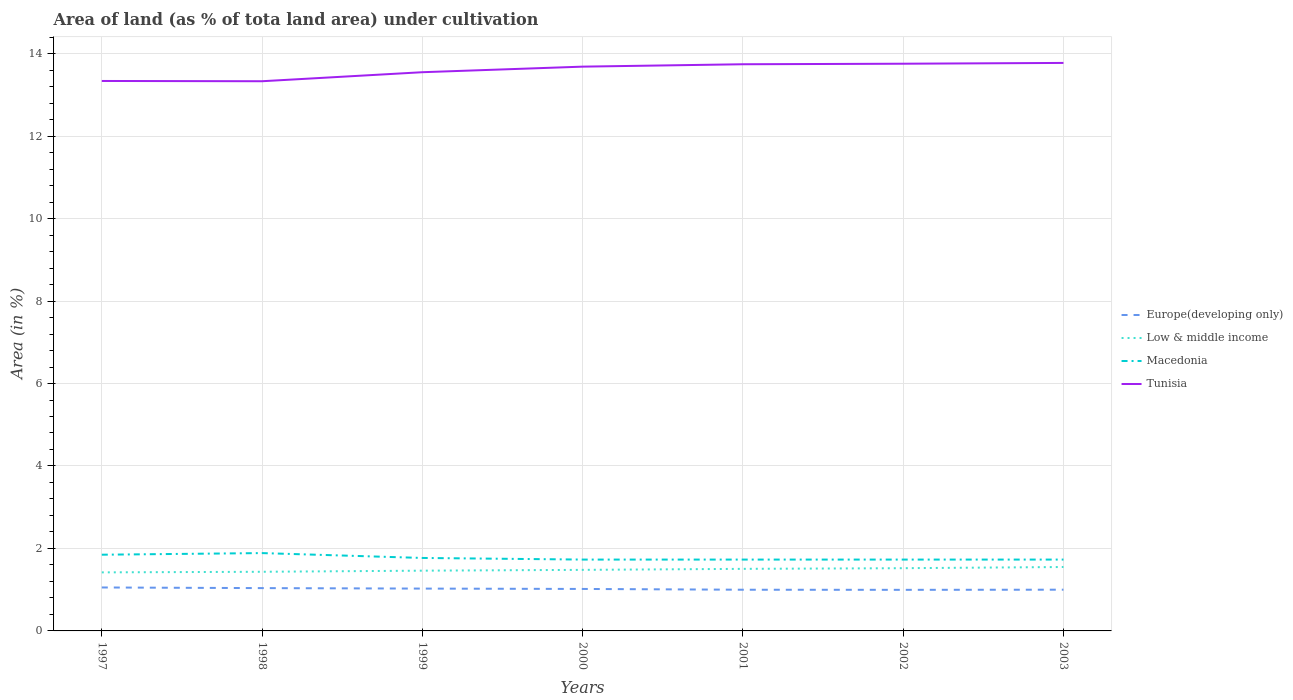Is the number of lines equal to the number of legend labels?
Provide a short and direct response. Yes. Across all years, what is the maximum percentage of land under cultivation in Macedonia?
Offer a very short reply. 1.73. In which year was the percentage of land under cultivation in Low & middle income maximum?
Make the answer very short. 1997. What is the total percentage of land under cultivation in Europe(developing only) in the graph?
Your answer should be compact. 0.03. What is the difference between the highest and the second highest percentage of land under cultivation in Europe(developing only)?
Provide a succinct answer. 0.06. What is the difference between the highest and the lowest percentage of land under cultivation in Low & middle income?
Offer a terse response. 3. What is the difference between two consecutive major ticks on the Y-axis?
Your answer should be very brief. 2. Does the graph contain any zero values?
Ensure brevity in your answer.  No. Does the graph contain grids?
Offer a very short reply. Yes. How many legend labels are there?
Ensure brevity in your answer.  4. What is the title of the graph?
Your answer should be very brief. Area of land (as % of tota land area) under cultivation. Does "Sub-Saharan Africa (developing only)" appear as one of the legend labels in the graph?
Your response must be concise. No. What is the label or title of the Y-axis?
Your answer should be compact. Area (in %). What is the Area (in %) in Europe(developing only) in 1997?
Provide a short and direct response. 1.05. What is the Area (in %) in Low & middle income in 1997?
Give a very brief answer. 1.42. What is the Area (in %) in Macedonia in 1997?
Your answer should be compact. 1.85. What is the Area (in %) in Tunisia in 1997?
Keep it short and to the point. 13.34. What is the Area (in %) in Europe(developing only) in 1998?
Make the answer very short. 1.04. What is the Area (in %) of Low & middle income in 1998?
Your response must be concise. 1.43. What is the Area (in %) in Macedonia in 1998?
Your response must be concise. 1.89. What is the Area (in %) in Tunisia in 1998?
Your response must be concise. 13.33. What is the Area (in %) in Europe(developing only) in 1999?
Your answer should be very brief. 1.03. What is the Area (in %) in Low & middle income in 1999?
Provide a short and direct response. 1.46. What is the Area (in %) of Macedonia in 1999?
Offer a very short reply. 1.77. What is the Area (in %) of Tunisia in 1999?
Give a very brief answer. 13.55. What is the Area (in %) in Europe(developing only) in 2000?
Offer a terse response. 1.02. What is the Area (in %) of Low & middle income in 2000?
Keep it short and to the point. 1.48. What is the Area (in %) of Macedonia in 2000?
Your response must be concise. 1.73. What is the Area (in %) in Tunisia in 2000?
Offer a very short reply. 13.68. What is the Area (in %) of Europe(developing only) in 2001?
Ensure brevity in your answer.  1. What is the Area (in %) in Low & middle income in 2001?
Keep it short and to the point. 1.51. What is the Area (in %) of Macedonia in 2001?
Your answer should be very brief. 1.73. What is the Area (in %) of Tunisia in 2001?
Provide a short and direct response. 13.74. What is the Area (in %) of Europe(developing only) in 2002?
Provide a succinct answer. 1. What is the Area (in %) in Low & middle income in 2002?
Your answer should be compact. 1.52. What is the Area (in %) of Macedonia in 2002?
Make the answer very short. 1.73. What is the Area (in %) of Tunisia in 2002?
Offer a terse response. 13.76. What is the Area (in %) in Europe(developing only) in 2003?
Make the answer very short. 1. What is the Area (in %) of Low & middle income in 2003?
Your response must be concise. 1.55. What is the Area (in %) in Macedonia in 2003?
Keep it short and to the point. 1.73. What is the Area (in %) in Tunisia in 2003?
Provide a short and direct response. 13.77. Across all years, what is the maximum Area (in %) of Europe(developing only)?
Provide a short and direct response. 1.05. Across all years, what is the maximum Area (in %) of Low & middle income?
Offer a very short reply. 1.55. Across all years, what is the maximum Area (in %) in Macedonia?
Ensure brevity in your answer.  1.89. Across all years, what is the maximum Area (in %) in Tunisia?
Make the answer very short. 13.77. Across all years, what is the minimum Area (in %) in Europe(developing only)?
Ensure brevity in your answer.  1. Across all years, what is the minimum Area (in %) of Low & middle income?
Your answer should be very brief. 1.42. Across all years, what is the minimum Area (in %) in Macedonia?
Ensure brevity in your answer.  1.73. Across all years, what is the minimum Area (in %) of Tunisia?
Give a very brief answer. 13.33. What is the total Area (in %) of Europe(developing only) in the graph?
Ensure brevity in your answer.  7.13. What is the total Area (in %) in Low & middle income in the graph?
Offer a terse response. 10.37. What is the total Area (in %) of Macedonia in the graph?
Your answer should be very brief. 12.43. What is the total Area (in %) in Tunisia in the graph?
Provide a succinct answer. 95.17. What is the difference between the Area (in %) of Europe(developing only) in 1997 and that in 1998?
Offer a very short reply. 0.02. What is the difference between the Area (in %) in Low & middle income in 1997 and that in 1998?
Your answer should be very brief. -0.01. What is the difference between the Area (in %) of Macedonia in 1997 and that in 1998?
Your answer should be compact. -0.04. What is the difference between the Area (in %) of Tunisia in 1997 and that in 1998?
Provide a succinct answer. 0.01. What is the difference between the Area (in %) of Europe(developing only) in 1997 and that in 1999?
Offer a terse response. 0.03. What is the difference between the Area (in %) of Low & middle income in 1997 and that in 1999?
Provide a short and direct response. -0.04. What is the difference between the Area (in %) of Macedonia in 1997 and that in 1999?
Offer a very short reply. 0.08. What is the difference between the Area (in %) of Tunisia in 1997 and that in 1999?
Your response must be concise. -0.21. What is the difference between the Area (in %) of Europe(developing only) in 1997 and that in 2000?
Provide a succinct answer. 0.04. What is the difference between the Area (in %) of Low & middle income in 1997 and that in 2000?
Your response must be concise. -0.06. What is the difference between the Area (in %) in Macedonia in 1997 and that in 2000?
Keep it short and to the point. 0.12. What is the difference between the Area (in %) in Tunisia in 1997 and that in 2000?
Keep it short and to the point. -0.35. What is the difference between the Area (in %) in Europe(developing only) in 1997 and that in 2001?
Give a very brief answer. 0.05. What is the difference between the Area (in %) of Low & middle income in 1997 and that in 2001?
Give a very brief answer. -0.09. What is the difference between the Area (in %) of Macedonia in 1997 and that in 2001?
Ensure brevity in your answer.  0.12. What is the difference between the Area (in %) in Tunisia in 1997 and that in 2001?
Provide a short and direct response. -0.41. What is the difference between the Area (in %) of Europe(developing only) in 1997 and that in 2002?
Your answer should be compact. 0.06. What is the difference between the Area (in %) of Low & middle income in 1997 and that in 2002?
Offer a very short reply. -0.1. What is the difference between the Area (in %) of Macedonia in 1997 and that in 2002?
Give a very brief answer. 0.12. What is the difference between the Area (in %) of Tunisia in 1997 and that in 2002?
Your response must be concise. -0.42. What is the difference between the Area (in %) of Europe(developing only) in 1997 and that in 2003?
Provide a short and direct response. 0.05. What is the difference between the Area (in %) of Low & middle income in 1997 and that in 2003?
Keep it short and to the point. -0.13. What is the difference between the Area (in %) of Macedonia in 1997 and that in 2003?
Offer a terse response. 0.12. What is the difference between the Area (in %) of Tunisia in 1997 and that in 2003?
Your answer should be compact. -0.44. What is the difference between the Area (in %) of Europe(developing only) in 1998 and that in 1999?
Provide a short and direct response. 0.01. What is the difference between the Area (in %) in Low & middle income in 1998 and that in 1999?
Give a very brief answer. -0.03. What is the difference between the Area (in %) in Macedonia in 1998 and that in 1999?
Offer a terse response. 0.12. What is the difference between the Area (in %) in Tunisia in 1998 and that in 1999?
Provide a short and direct response. -0.22. What is the difference between the Area (in %) of Europe(developing only) in 1998 and that in 2000?
Make the answer very short. 0.02. What is the difference between the Area (in %) in Low & middle income in 1998 and that in 2000?
Ensure brevity in your answer.  -0.05. What is the difference between the Area (in %) in Macedonia in 1998 and that in 2000?
Make the answer very short. 0.16. What is the difference between the Area (in %) in Tunisia in 1998 and that in 2000?
Offer a terse response. -0.35. What is the difference between the Area (in %) of Europe(developing only) in 1998 and that in 2001?
Offer a very short reply. 0.04. What is the difference between the Area (in %) of Low & middle income in 1998 and that in 2001?
Provide a short and direct response. -0.07. What is the difference between the Area (in %) in Macedonia in 1998 and that in 2001?
Offer a very short reply. 0.16. What is the difference between the Area (in %) of Tunisia in 1998 and that in 2001?
Your answer should be very brief. -0.41. What is the difference between the Area (in %) of Europe(developing only) in 1998 and that in 2002?
Provide a short and direct response. 0.04. What is the difference between the Area (in %) in Low & middle income in 1998 and that in 2002?
Provide a succinct answer. -0.09. What is the difference between the Area (in %) of Macedonia in 1998 and that in 2002?
Your answer should be compact. 0.16. What is the difference between the Area (in %) in Tunisia in 1998 and that in 2002?
Provide a succinct answer. -0.42. What is the difference between the Area (in %) of Europe(developing only) in 1998 and that in 2003?
Keep it short and to the point. 0.04. What is the difference between the Area (in %) in Low & middle income in 1998 and that in 2003?
Make the answer very short. -0.12. What is the difference between the Area (in %) in Macedonia in 1998 and that in 2003?
Offer a terse response. 0.16. What is the difference between the Area (in %) in Tunisia in 1998 and that in 2003?
Provide a succinct answer. -0.44. What is the difference between the Area (in %) of Europe(developing only) in 1999 and that in 2000?
Keep it short and to the point. 0.01. What is the difference between the Area (in %) in Low & middle income in 1999 and that in 2000?
Give a very brief answer. -0.02. What is the difference between the Area (in %) in Macedonia in 1999 and that in 2000?
Provide a succinct answer. 0.04. What is the difference between the Area (in %) of Tunisia in 1999 and that in 2000?
Offer a terse response. -0.14. What is the difference between the Area (in %) in Europe(developing only) in 1999 and that in 2001?
Your answer should be very brief. 0.03. What is the difference between the Area (in %) in Low & middle income in 1999 and that in 2001?
Keep it short and to the point. -0.04. What is the difference between the Area (in %) in Macedonia in 1999 and that in 2001?
Keep it short and to the point. 0.04. What is the difference between the Area (in %) of Tunisia in 1999 and that in 2001?
Keep it short and to the point. -0.19. What is the difference between the Area (in %) in Europe(developing only) in 1999 and that in 2002?
Your answer should be compact. 0.03. What is the difference between the Area (in %) in Low & middle income in 1999 and that in 2002?
Provide a short and direct response. -0.06. What is the difference between the Area (in %) in Macedonia in 1999 and that in 2002?
Your answer should be very brief. 0.04. What is the difference between the Area (in %) in Tunisia in 1999 and that in 2002?
Your answer should be very brief. -0.21. What is the difference between the Area (in %) in Europe(developing only) in 1999 and that in 2003?
Offer a very short reply. 0.03. What is the difference between the Area (in %) of Low & middle income in 1999 and that in 2003?
Make the answer very short. -0.09. What is the difference between the Area (in %) of Macedonia in 1999 and that in 2003?
Make the answer very short. 0.04. What is the difference between the Area (in %) in Tunisia in 1999 and that in 2003?
Your answer should be very brief. -0.23. What is the difference between the Area (in %) in Europe(developing only) in 2000 and that in 2001?
Make the answer very short. 0.02. What is the difference between the Area (in %) in Low & middle income in 2000 and that in 2001?
Keep it short and to the point. -0.02. What is the difference between the Area (in %) of Macedonia in 2000 and that in 2001?
Provide a succinct answer. 0. What is the difference between the Area (in %) of Tunisia in 2000 and that in 2001?
Your answer should be compact. -0.06. What is the difference between the Area (in %) in Europe(developing only) in 2000 and that in 2002?
Offer a terse response. 0.02. What is the difference between the Area (in %) in Low & middle income in 2000 and that in 2002?
Make the answer very short. -0.04. What is the difference between the Area (in %) in Tunisia in 2000 and that in 2002?
Your answer should be compact. -0.07. What is the difference between the Area (in %) of Europe(developing only) in 2000 and that in 2003?
Your answer should be compact. 0.02. What is the difference between the Area (in %) of Low & middle income in 2000 and that in 2003?
Ensure brevity in your answer.  -0.07. What is the difference between the Area (in %) of Macedonia in 2000 and that in 2003?
Your response must be concise. 0. What is the difference between the Area (in %) in Tunisia in 2000 and that in 2003?
Provide a short and direct response. -0.09. What is the difference between the Area (in %) of Europe(developing only) in 2001 and that in 2002?
Your answer should be very brief. 0. What is the difference between the Area (in %) of Low & middle income in 2001 and that in 2002?
Your response must be concise. -0.02. What is the difference between the Area (in %) in Tunisia in 2001 and that in 2002?
Your answer should be very brief. -0.01. What is the difference between the Area (in %) in Europe(developing only) in 2001 and that in 2003?
Provide a succinct answer. -0. What is the difference between the Area (in %) of Low & middle income in 2001 and that in 2003?
Ensure brevity in your answer.  -0.04. What is the difference between the Area (in %) of Macedonia in 2001 and that in 2003?
Ensure brevity in your answer.  0. What is the difference between the Area (in %) in Tunisia in 2001 and that in 2003?
Your answer should be very brief. -0.03. What is the difference between the Area (in %) of Europe(developing only) in 2002 and that in 2003?
Your answer should be very brief. -0. What is the difference between the Area (in %) in Low & middle income in 2002 and that in 2003?
Make the answer very short. -0.03. What is the difference between the Area (in %) of Macedonia in 2002 and that in 2003?
Ensure brevity in your answer.  0. What is the difference between the Area (in %) in Tunisia in 2002 and that in 2003?
Your answer should be very brief. -0.02. What is the difference between the Area (in %) in Europe(developing only) in 1997 and the Area (in %) in Low & middle income in 1998?
Offer a terse response. -0.38. What is the difference between the Area (in %) of Europe(developing only) in 1997 and the Area (in %) of Macedonia in 1998?
Offer a very short reply. -0.83. What is the difference between the Area (in %) of Europe(developing only) in 1997 and the Area (in %) of Tunisia in 1998?
Ensure brevity in your answer.  -12.28. What is the difference between the Area (in %) in Low & middle income in 1997 and the Area (in %) in Macedonia in 1998?
Your answer should be very brief. -0.47. What is the difference between the Area (in %) in Low & middle income in 1997 and the Area (in %) in Tunisia in 1998?
Offer a very short reply. -11.91. What is the difference between the Area (in %) in Macedonia in 1997 and the Area (in %) in Tunisia in 1998?
Offer a terse response. -11.48. What is the difference between the Area (in %) of Europe(developing only) in 1997 and the Area (in %) of Low & middle income in 1999?
Your response must be concise. -0.41. What is the difference between the Area (in %) of Europe(developing only) in 1997 and the Area (in %) of Macedonia in 1999?
Provide a short and direct response. -0.72. What is the difference between the Area (in %) of Europe(developing only) in 1997 and the Area (in %) of Tunisia in 1999?
Keep it short and to the point. -12.5. What is the difference between the Area (in %) of Low & middle income in 1997 and the Area (in %) of Macedonia in 1999?
Ensure brevity in your answer.  -0.35. What is the difference between the Area (in %) of Low & middle income in 1997 and the Area (in %) of Tunisia in 1999?
Offer a terse response. -12.13. What is the difference between the Area (in %) in Macedonia in 1997 and the Area (in %) in Tunisia in 1999?
Your answer should be compact. -11.7. What is the difference between the Area (in %) of Europe(developing only) in 1997 and the Area (in %) of Low & middle income in 2000?
Give a very brief answer. -0.43. What is the difference between the Area (in %) of Europe(developing only) in 1997 and the Area (in %) of Macedonia in 2000?
Your answer should be very brief. -0.68. What is the difference between the Area (in %) of Europe(developing only) in 1997 and the Area (in %) of Tunisia in 2000?
Keep it short and to the point. -12.63. What is the difference between the Area (in %) of Low & middle income in 1997 and the Area (in %) of Macedonia in 2000?
Offer a terse response. -0.31. What is the difference between the Area (in %) of Low & middle income in 1997 and the Area (in %) of Tunisia in 2000?
Give a very brief answer. -12.26. What is the difference between the Area (in %) of Macedonia in 1997 and the Area (in %) of Tunisia in 2000?
Offer a very short reply. -11.84. What is the difference between the Area (in %) of Europe(developing only) in 1997 and the Area (in %) of Low & middle income in 2001?
Ensure brevity in your answer.  -0.45. What is the difference between the Area (in %) of Europe(developing only) in 1997 and the Area (in %) of Macedonia in 2001?
Provide a short and direct response. -0.68. What is the difference between the Area (in %) of Europe(developing only) in 1997 and the Area (in %) of Tunisia in 2001?
Provide a short and direct response. -12.69. What is the difference between the Area (in %) in Low & middle income in 1997 and the Area (in %) in Macedonia in 2001?
Your response must be concise. -0.31. What is the difference between the Area (in %) of Low & middle income in 1997 and the Area (in %) of Tunisia in 2001?
Offer a terse response. -12.32. What is the difference between the Area (in %) of Macedonia in 1997 and the Area (in %) of Tunisia in 2001?
Offer a terse response. -11.89. What is the difference between the Area (in %) of Europe(developing only) in 1997 and the Area (in %) of Low & middle income in 2002?
Your answer should be compact. -0.47. What is the difference between the Area (in %) in Europe(developing only) in 1997 and the Area (in %) in Macedonia in 2002?
Make the answer very short. -0.68. What is the difference between the Area (in %) of Europe(developing only) in 1997 and the Area (in %) of Tunisia in 2002?
Your answer should be very brief. -12.7. What is the difference between the Area (in %) in Low & middle income in 1997 and the Area (in %) in Macedonia in 2002?
Give a very brief answer. -0.31. What is the difference between the Area (in %) in Low & middle income in 1997 and the Area (in %) in Tunisia in 2002?
Offer a very short reply. -12.34. What is the difference between the Area (in %) in Macedonia in 1997 and the Area (in %) in Tunisia in 2002?
Make the answer very short. -11.91. What is the difference between the Area (in %) of Europe(developing only) in 1997 and the Area (in %) of Low & middle income in 2003?
Provide a short and direct response. -0.5. What is the difference between the Area (in %) of Europe(developing only) in 1997 and the Area (in %) of Macedonia in 2003?
Your response must be concise. -0.68. What is the difference between the Area (in %) in Europe(developing only) in 1997 and the Area (in %) in Tunisia in 2003?
Offer a very short reply. -12.72. What is the difference between the Area (in %) of Low & middle income in 1997 and the Area (in %) of Macedonia in 2003?
Offer a very short reply. -0.31. What is the difference between the Area (in %) of Low & middle income in 1997 and the Area (in %) of Tunisia in 2003?
Provide a short and direct response. -12.35. What is the difference between the Area (in %) of Macedonia in 1997 and the Area (in %) of Tunisia in 2003?
Your answer should be very brief. -11.93. What is the difference between the Area (in %) in Europe(developing only) in 1998 and the Area (in %) in Low & middle income in 1999?
Your response must be concise. -0.42. What is the difference between the Area (in %) of Europe(developing only) in 1998 and the Area (in %) of Macedonia in 1999?
Your answer should be very brief. -0.73. What is the difference between the Area (in %) of Europe(developing only) in 1998 and the Area (in %) of Tunisia in 1999?
Provide a succinct answer. -12.51. What is the difference between the Area (in %) of Low & middle income in 1998 and the Area (in %) of Macedonia in 1999?
Your answer should be very brief. -0.34. What is the difference between the Area (in %) of Low & middle income in 1998 and the Area (in %) of Tunisia in 1999?
Your response must be concise. -12.11. What is the difference between the Area (in %) of Macedonia in 1998 and the Area (in %) of Tunisia in 1999?
Provide a short and direct response. -11.66. What is the difference between the Area (in %) in Europe(developing only) in 1998 and the Area (in %) in Low & middle income in 2000?
Offer a terse response. -0.44. What is the difference between the Area (in %) of Europe(developing only) in 1998 and the Area (in %) of Macedonia in 2000?
Give a very brief answer. -0.69. What is the difference between the Area (in %) in Europe(developing only) in 1998 and the Area (in %) in Tunisia in 2000?
Keep it short and to the point. -12.65. What is the difference between the Area (in %) of Low & middle income in 1998 and the Area (in %) of Macedonia in 2000?
Make the answer very short. -0.3. What is the difference between the Area (in %) of Low & middle income in 1998 and the Area (in %) of Tunisia in 2000?
Offer a terse response. -12.25. What is the difference between the Area (in %) in Macedonia in 1998 and the Area (in %) in Tunisia in 2000?
Ensure brevity in your answer.  -11.8. What is the difference between the Area (in %) in Europe(developing only) in 1998 and the Area (in %) in Low & middle income in 2001?
Keep it short and to the point. -0.47. What is the difference between the Area (in %) of Europe(developing only) in 1998 and the Area (in %) of Macedonia in 2001?
Give a very brief answer. -0.69. What is the difference between the Area (in %) of Europe(developing only) in 1998 and the Area (in %) of Tunisia in 2001?
Make the answer very short. -12.7. What is the difference between the Area (in %) of Low & middle income in 1998 and the Area (in %) of Macedonia in 2001?
Provide a succinct answer. -0.3. What is the difference between the Area (in %) of Low & middle income in 1998 and the Area (in %) of Tunisia in 2001?
Your answer should be compact. -12.31. What is the difference between the Area (in %) of Macedonia in 1998 and the Area (in %) of Tunisia in 2001?
Make the answer very short. -11.85. What is the difference between the Area (in %) in Europe(developing only) in 1998 and the Area (in %) in Low & middle income in 2002?
Your answer should be very brief. -0.48. What is the difference between the Area (in %) of Europe(developing only) in 1998 and the Area (in %) of Macedonia in 2002?
Your answer should be compact. -0.69. What is the difference between the Area (in %) in Europe(developing only) in 1998 and the Area (in %) in Tunisia in 2002?
Provide a succinct answer. -12.72. What is the difference between the Area (in %) of Low & middle income in 1998 and the Area (in %) of Macedonia in 2002?
Offer a terse response. -0.3. What is the difference between the Area (in %) of Low & middle income in 1998 and the Area (in %) of Tunisia in 2002?
Offer a very short reply. -12.32. What is the difference between the Area (in %) in Macedonia in 1998 and the Area (in %) in Tunisia in 2002?
Your response must be concise. -11.87. What is the difference between the Area (in %) of Europe(developing only) in 1998 and the Area (in %) of Low & middle income in 2003?
Make the answer very short. -0.51. What is the difference between the Area (in %) in Europe(developing only) in 1998 and the Area (in %) in Macedonia in 2003?
Your response must be concise. -0.69. What is the difference between the Area (in %) of Europe(developing only) in 1998 and the Area (in %) of Tunisia in 2003?
Your response must be concise. -12.74. What is the difference between the Area (in %) in Low & middle income in 1998 and the Area (in %) in Macedonia in 2003?
Your response must be concise. -0.3. What is the difference between the Area (in %) in Low & middle income in 1998 and the Area (in %) in Tunisia in 2003?
Offer a terse response. -12.34. What is the difference between the Area (in %) in Macedonia in 1998 and the Area (in %) in Tunisia in 2003?
Your response must be concise. -11.89. What is the difference between the Area (in %) in Europe(developing only) in 1999 and the Area (in %) in Low & middle income in 2000?
Your answer should be compact. -0.45. What is the difference between the Area (in %) of Europe(developing only) in 1999 and the Area (in %) of Macedonia in 2000?
Your answer should be very brief. -0.7. What is the difference between the Area (in %) of Europe(developing only) in 1999 and the Area (in %) of Tunisia in 2000?
Offer a terse response. -12.66. What is the difference between the Area (in %) in Low & middle income in 1999 and the Area (in %) in Macedonia in 2000?
Your answer should be very brief. -0.27. What is the difference between the Area (in %) of Low & middle income in 1999 and the Area (in %) of Tunisia in 2000?
Provide a succinct answer. -12.22. What is the difference between the Area (in %) of Macedonia in 1999 and the Area (in %) of Tunisia in 2000?
Your answer should be compact. -11.91. What is the difference between the Area (in %) in Europe(developing only) in 1999 and the Area (in %) in Low & middle income in 2001?
Provide a succinct answer. -0.48. What is the difference between the Area (in %) in Europe(developing only) in 1999 and the Area (in %) in Macedonia in 2001?
Ensure brevity in your answer.  -0.7. What is the difference between the Area (in %) in Europe(developing only) in 1999 and the Area (in %) in Tunisia in 2001?
Offer a very short reply. -12.72. What is the difference between the Area (in %) of Low & middle income in 1999 and the Area (in %) of Macedonia in 2001?
Offer a very short reply. -0.27. What is the difference between the Area (in %) of Low & middle income in 1999 and the Area (in %) of Tunisia in 2001?
Provide a short and direct response. -12.28. What is the difference between the Area (in %) of Macedonia in 1999 and the Area (in %) of Tunisia in 2001?
Ensure brevity in your answer.  -11.97. What is the difference between the Area (in %) in Europe(developing only) in 1999 and the Area (in %) in Low & middle income in 2002?
Provide a succinct answer. -0.49. What is the difference between the Area (in %) of Europe(developing only) in 1999 and the Area (in %) of Macedonia in 2002?
Provide a succinct answer. -0.7. What is the difference between the Area (in %) of Europe(developing only) in 1999 and the Area (in %) of Tunisia in 2002?
Offer a terse response. -12.73. What is the difference between the Area (in %) in Low & middle income in 1999 and the Area (in %) in Macedonia in 2002?
Give a very brief answer. -0.27. What is the difference between the Area (in %) of Low & middle income in 1999 and the Area (in %) of Tunisia in 2002?
Make the answer very short. -12.29. What is the difference between the Area (in %) in Macedonia in 1999 and the Area (in %) in Tunisia in 2002?
Provide a short and direct response. -11.99. What is the difference between the Area (in %) of Europe(developing only) in 1999 and the Area (in %) of Low & middle income in 2003?
Provide a short and direct response. -0.52. What is the difference between the Area (in %) in Europe(developing only) in 1999 and the Area (in %) in Macedonia in 2003?
Keep it short and to the point. -0.7. What is the difference between the Area (in %) of Europe(developing only) in 1999 and the Area (in %) of Tunisia in 2003?
Make the answer very short. -12.75. What is the difference between the Area (in %) in Low & middle income in 1999 and the Area (in %) in Macedonia in 2003?
Make the answer very short. -0.27. What is the difference between the Area (in %) in Low & middle income in 1999 and the Area (in %) in Tunisia in 2003?
Offer a very short reply. -12.31. What is the difference between the Area (in %) of Macedonia in 1999 and the Area (in %) of Tunisia in 2003?
Your answer should be very brief. -12. What is the difference between the Area (in %) of Europe(developing only) in 2000 and the Area (in %) of Low & middle income in 2001?
Provide a short and direct response. -0.49. What is the difference between the Area (in %) in Europe(developing only) in 2000 and the Area (in %) in Macedonia in 2001?
Offer a very short reply. -0.71. What is the difference between the Area (in %) in Europe(developing only) in 2000 and the Area (in %) in Tunisia in 2001?
Provide a short and direct response. -12.72. What is the difference between the Area (in %) of Low & middle income in 2000 and the Area (in %) of Macedonia in 2001?
Offer a terse response. -0.25. What is the difference between the Area (in %) in Low & middle income in 2000 and the Area (in %) in Tunisia in 2001?
Give a very brief answer. -12.26. What is the difference between the Area (in %) of Macedonia in 2000 and the Area (in %) of Tunisia in 2001?
Your response must be concise. -12.01. What is the difference between the Area (in %) of Europe(developing only) in 2000 and the Area (in %) of Low & middle income in 2002?
Your response must be concise. -0.5. What is the difference between the Area (in %) in Europe(developing only) in 2000 and the Area (in %) in Macedonia in 2002?
Give a very brief answer. -0.71. What is the difference between the Area (in %) in Europe(developing only) in 2000 and the Area (in %) in Tunisia in 2002?
Offer a terse response. -12.74. What is the difference between the Area (in %) in Low & middle income in 2000 and the Area (in %) in Macedonia in 2002?
Offer a very short reply. -0.25. What is the difference between the Area (in %) in Low & middle income in 2000 and the Area (in %) in Tunisia in 2002?
Keep it short and to the point. -12.27. What is the difference between the Area (in %) in Macedonia in 2000 and the Area (in %) in Tunisia in 2002?
Your answer should be very brief. -12.02. What is the difference between the Area (in %) of Europe(developing only) in 2000 and the Area (in %) of Low & middle income in 2003?
Offer a very short reply. -0.53. What is the difference between the Area (in %) in Europe(developing only) in 2000 and the Area (in %) in Macedonia in 2003?
Offer a terse response. -0.71. What is the difference between the Area (in %) in Europe(developing only) in 2000 and the Area (in %) in Tunisia in 2003?
Offer a very short reply. -12.76. What is the difference between the Area (in %) of Low & middle income in 2000 and the Area (in %) of Macedonia in 2003?
Offer a terse response. -0.25. What is the difference between the Area (in %) in Low & middle income in 2000 and the Area (in %) in Tunisia in 2003?
Give a very brief answer. -12.29. What is the difference between the Area (in %) of Macedonia in 2000 and the Area (in %) of Tunisia in 2003?
Offer a very short reply. -12.04. What is the difference between the Area (in %) in Europe(developing only) in 2001 and the Area (in %) in Low & middle income in 2002?
Offer a very short reply. -0.52. What is the difference between the Area (in %) of Europe(developing only) in 2001 and the Area (in %) of Macedonia in 2002?
Ensure brevity in your answer.  -0.73. What is the difference between the Area (in %) in Europe(developing only) in 2001 and the Area (in %) in Tunisia in 2002?
Offer a very short reply. -12.76. What is the difference between the Area (in %) in Low & middle income in 2001 and the Area (in %) in Macedonia in 2002?
Provide a succinct answer. -0.22. What is the difference between the Area (in %) of Low & middle income in 2001 and the Area (in %) of Tunisia in 2002?
Ensure brevity in your answer.  -12.25. What is the difference between the Area (in %) in Macedonia in 2001 and the Area (in %) in Tunisia in 2002?
Keep it short and to the point. -12.02. What is the difference between the Area (in %) of Europe(developing only) in 2001 and the Area (in %) of Low & middle income in 2003?
Ensure brevity in your answer.  -0.55. What is the difference between the Area (in %) in Europe(developing only) in 2001 and the Area (in %) in Macedonia in 2003?
Your answer should be compact. -0.73. What is the difference between the Area (in %) in Europe(developing only) in 2001 and the Area (in %) in Tunisia in 2003?
Your answer should be very brief. -12.78. What is the difference between the Area (in %) of Low & middle income in 2001 and the Area (in %) of Macedonia in 2003?
Your response must be concise. -0.22. What is the difference between the Area (in %) of Low & middle income in 2001 and the Area (in %) of Tunisia in 2003?
Give a very brief answer. -12.27. What is the difference between the Area (in %) of Macedonia in 2001 and the Area (in %) of Tunisia in 2003?
Ensure brevity in your answer.  -12.04. What is the difference between the Area (in %) in Europe(developing only) in 2002 and the Area (in %) in Low & middle income in 2003?
Provide a succinct answer. -0.55. What is the difference between the Area (in %) in Europe(developing only) in 2002 and the Area (in %) in Macedonia in 2003?
Offer a very short reply. -0.73. What is the difference between the Area (in %) of Europe(developing only) in 2002 and the Area (in %) of Tunisia in 2003?
Offer a terse response. -12.78. What is the difference between the Area (in %) in Low & middle income in 2002 and the Area (in %) in Macedonia in 2003?
Ensure brevity in your answer.  -0.21. What is the difference between the Area (in %) of Low & middle income in 2002 and the Area (in %) of Tunisia in 2003?
Your answer should be compact. -12.25. What is the difference between the Area (in %) of Macedonia in 2002 and the Area (in %) of Tunisia in 2003?
Offer a very short reply. -12.04. What is the average Area (in %) of Europe(developing only) per year?
Give a very brief answer. 1.02. What is the average Area (in %) of Low & middle income per year?
Your response must be concise. 1.48. What is the average Area (in %) of Macedonia per year?
Your answer should be very brief. 1.78. What is the average Area (in %) in Tunisia per year?
Provide a short and direct response. 13.6. In the year 1997, what is the difference between the Area (in %) of Europe(developing only) and Area (in %) of Low & middle income?
Your answer should be very brief. -0.37. In the year 1997, what is the difference between the Area (in %) in Europe(developing only) and Area (in %) in Macedonia?
Ensure brevity in your answer.  -0.79. In the year 1997, what is the difference between the Area (in %) in Europe(developing only) and Area (in %) in Tunisia?
Your answer should be very brief. -12.28. In the year 1997, what is the difference between the Area (in %) in Low & middle income and Area (in %) in Macedonia?
Your answer should be very brief. -0.43. In the year 1997, what is the difference between the Area (in %) of Low & middle income and Area (in %) of Tunisia?
Offer a terse response. -11.92. In the year 1997, what is the difference between the Area (in %) of Macedonia and Area (in %) of Tunisia?
Offer a terse response. -11.49. In the year 1998, what is the difference between the Area (in %) of Europe(developing only) and Area (in %) of Low & middle income?
Give a very brief answer. -0.4. In the year 1998, what is the difference between the Area (in %) of Europe(developing only) and Area (in %) of Macedonia?
Make the answer very short. -0.85. In the year 1998, what is the difference between the Area (in %) of Europe(developing only) and Area (in %) of Tunisia?
Offer a very short reply. -12.29. In the year 1998, what is the difference between the Area (in %) in Low & middle income and Area (in %) in Macedonia?
Provide a short and direct response. -0.45. In the year 1998, what is the difference between the Area (in %) of Low & middle income and Area (in %) of Tunisia?
Provide a succinct answer. -11.9. In the year 1998, what is the difference between the Area (in %) of Macedonia and Area (in %) of Tunisia?
Give a very brief answer. -11.44. In the year 1999, what is the difference between the Area (in %) in Europe(developing only) and Area (in %) in Low & middle income?
Your answer should be very brief. -0.43. In the year 1999, what is the difference between the Area (in %) of Europe(developing only) and Area (in %) of Macedonia?
Make the answer very short. -0.74. In the year 1999, what is the difference between the Area (in %) in Europe(developing only) and Area (in %) in Tunisia?
Offer a terse response. -12.52. In the year 1999, what is the difference between the Area (in %) in Low & middle income and Area (in %) in Macedonia?
Keep it short and to the point. -0.31. In the year 1999, what is the difference between the Area (in %) of Low & middle income and Area (in %) of Tunisia?
Your answer should be compact. -12.09. In the year 1999, what is the difference between the Area (in %) in Macedonia and Area (in %) in Tunisia?
Keep it short and to the point. -11.78. In the year 2000, what is the difference between the Area (in %) of Europe(developing only) and Area (in %) of Low & middle income?
Provide a short and direct response. -0.46. In the year 2000, what is the difference between the Area (in %) of Europe(developing only) and Area (in %) of Macedonia?
Give a very brief answer. -0.71. In the year 2000, what is the difference between the Area (in %) of Europe(developing only) and Area (in %) of Tunisia?
Your answer should be very brief. -12.67. In the year 2000, what is the difference between the Area (in %) in Low & middle income and Area (in %) in Macedonia?
Make the answer very short. -0.25. In the year 2000, what is the difference between the Area (in %) of Low & middle income and Area (in %) of Tunisia?
Provide a succinct answer. -12.2. In the year 2000, what is the difference between the Area (in %) in Macedonia and Area (in %) in Tunisia?
Offer a terse response. -11.95. In the year 2001, what is the difference between the Area (in %) in Europe(developing only) and Area (in %) in Low & middle income?
Make the answer very short. -0.51. In the year 2001, what is the difference between the Area (in %) of Europe(developing only) and Area (in %) of Macedonia?
Offer a terse response. -0.73. In the year 2001, what is the difference between the Area (in %) of Europe(developing only) and Area (in %) of Tunisia?
Your response must be concise. -12.74. In the year 2001, what is the difference between the Area (in %) in Low & middle income and Area (in %) in Macedonia?
Provide a short and direct response. -0.22. In the year 2001, what is the difference between the Area (in %) in Low & middle income and Area (in %) in Tunisia?
Give a very brief answer. -12.24. In the year 2001, what is the difference between the Area (in %) in Macedonia and Area (in %) in Tunisia?
Offer a terse response. -12.01. In the year 2002, what is the difference between the Area (in %) in Europe(developing only) and Area (in %) in Low & middle income?
Provide a succinct answer. -0.53. In the year 2002, what is the difference between the Area (in %) in Europe(developing only) and Area (in %) in Macedonia?
Ensure brevity in your answer.  -0.73. In the year 2002, what is the difference between the Area (in %) in Europe(developing only) and Area (in %) in Tunisia?
Your response must be concise. -12.76. In the year 2002, what is the difference between the Area (in %) of Low & middle income and Area (in %) of Macedonia?
Your response must be concise. -0.21. In the year 2002, what is the difference between the Area (in %) in Low & middle income and Area (in %) in Tunisia?
Provide a short and direct response. -12.23. In the year 2002, what is the difference between the Area (in %) in Macedonia and Area (in %) in Tunisia?
Give a very brief answer. -12.02. In the year 2003, what is the difference between the Area (in %) of Europe(developing only) and Area (in %) of Low & middle income?
Offer a terse response. -0.55. In the year 2003, what is the difference between the Area (in %) of Europe(developing only) and Area (in %) of Macedonia?
Your answer should be compact. -0.73. In the year 2003, what is the difference between the Area (in %) in Europe(developing only) and Area (in %) in Tunisia?
Your response must be concise. -12.77. In the year 2003, what is the difference between the Area (in %) in Low & middle income and Area (in %) in Macedonia?
Offer a very short reply. -0.18. In the year 2003, what is the difference between the Area (in %) in Low & middle income and Area (in %) in Tunisia?
Keep it short and to the point. -12.22. In the year 2003, what is the difference between the Area (in %) of Macedonia and Area (in %) of Tunisia?
Offer a very short reply. -12.04. What is the ratio of the Area (in %) in Europe(developing only) in 1997 to that in 1998?
Your answer should be very brief. 1.01. What is the ratio of the Area (in %) in Low & middle income in 1997 to that in 1998?
Ensure brevity in your answer.  0.99. What is the ratio of the Area (in %) in Macedonia in 1997 to that in 1998?
Your answer should be very brief. 0.98. What is the ratio of the Area (in %) in Tunisia in 1997 to that in 1998?
Your answer should be very brief. 1. What is the ratio of the Area (in %) of Europe(developing only) in 1997 to that in 1999?
Make the answer very short. 1.03. What is the ratio of the Area (in %) in Low & middle income in 1997 to that in 1999?
Make the answer very short. 0.97. What is the ratio of the Area (in %) of Macedonia in 1997 to that in 1999?
Your answer should be very brief. 1.04. What is the ratio of the Area (in %) of Tunisia in 1997 to that in 1999?
Your response must be concise. 0.98. What is the ratio of the Area (in %) in Europe(developing only) in 1997 to that in 2000?
Your answer should be compact. 1.03. What is the ratio of the Area (in %) in Macedonia in 1997 to that in 2000?
Make the answer very short. 1.07. What is the ratio of the Area (in %) of Tunisia in 1997 to that in 2000?
Offer a terse response. 0.97. What is the ratio of the Area (in %) in Europe(developing only) in 1997 to that in 2001?
Make the answer very short. 1.05. What is the ratio of the Area (in %) in Low & middle income in 1997 to that in 2001?
Make the answer very short. 0.94. What is the ratio of the Area (in %) in Macedonia in 1997 to that in 2001?
Provide a succinct answer. 1.07. What is the ratio of the Area (in %) in Tunisia in 1997 to that in 2001?
Keep it short and to the point. 0.97. What is the ratio of the Area (in %) in Europe(developing only) in 1997 to that in 2002?
Offer a very short reply. 1.06. What is the ratio of the Area (in %) in Low & middle income in 1997 to that in 2002?
Offer a terse response. 0.93. What is the ratio of the Area (in %) of Macedonia in 1997 to that in 2002?
Provide a short and direct response. 1.07. What is the ratio of the Area (in %) in Tunisia in 1997 to that in 2002?
Offer a very short reply. 0.97. What is the ratio of the Area (in %) of Europe(developing only) in 1997 to that in 2003?
Make the answer very short. 1.05. What is the ratio of the Area (in %) of Low & middle income in 1997 to that in 2003?
Your answer should be very brief. 0.92. What is the ratio of the Area (in %) of Macedonia in 1997 to that in 2003?
Your answer should be very brief. 1.07. What is the ratio of the Area (in %) of Tunisia in 1997 to that in 2003?
Your response must be concise. 0.97. What is the ratio of the Area (in %) of Europe(developing only) in 1998 to that in 1999?
Give a very brief answer. 1.01. What is the ratio of the Area (in %) of Low & middle income in 1998 to that in 1999?
Offer a very short reply. 0.98. What is the ratio of the Area (in %) of Macedonia in 1998 to that in 1999?
Provide a succinct answer. 1.07. What is the ratio of the Area (in %) of Tunisia in 1998 to that in 1999?
Ensure brevity in your answer.  0.98. What is the ratio of the Area (in %) in Europe(developing only) in 1998 to that in 2000?
Ensure brevity in your answer.  1.02. What is the ratio of the Area (in %) of Low & middle income in 1998 to that in 2000?
Ensure brevity in your answer.  0.97. What is the ratio of the Area (in %) of Tunisia in 1998 to that in 2000?
Provide a succinct answer. 0.97. What is the ratio of the Area (in %) in Europe(developing only) in 1998 to that in 2001?
Keep it short and to the point. 1.04. What is the ratio of the Area (in %) in Low & middle income in 1998 to that in 2001?
Make the answer very short. 0.95. What is the ratio of the Area (in %) of Europe(developing only) in 1998 to that in 2002?
Offer a terse response. 1.04. What is the ratio of the Area (in %) of Low & middle income in 1998 to that in 2002?
Offer a very short reply. 0.94. What is the ratio of the Area (in %) in Tunisia in 1998 to that in 2002?
Provide a succinct answer. 0.97. What is the ratio of the Area (in %) in Europe(developing only) in 1998 to that in 2003?
Offer a very short reply. 1.04. What is the ratio of the Area (in %) of Low & middle income in 1998 to that in 2003?
Give a very brief answer. 0.93. What is the ratio of the Area (in %) of Tunisia in 1998 to that in 2003?
Your answer should be very brief. 0.97. What is the ratio of the Area (in %) in Europe(developing only) in 1999 to that in 2000?
Your answer should be compact. 1.01. What is the ratio of the Area (in %) of Low & middle income in 1999 to that in 2000?
Your response must be concise. 0.99. What is the ratio of the Area (in %) in Macedonia in 1999 to that in 2000?
Offer a terse response. 1.02. What is the ratio of the Area (in %) in Tunisia in 1999 to that in 2000?
Provide a short and direct response. 0.99. What is the ratio of the Area (in %) in Europe(developing only) in 1999 to that in 2001?
Offer a very short reply. 1.03. What is the ratio of the Area (in %) in Low & middle income in 1999 to that in 2001?
Make the answer very short. 0.97. What is the ratio of the Area (in %) of Macedonia in 1999 to that in 2001?
Ensure brevity in your answer.  1.02. What is the ratio of the Area (in %) in Tunisia in 1999 to that in 2001?
Ensure brevity in your answer.  0.99. What is the ratio of the Area (in %) of Europe(developing only) in 1999 to that in 2002?
Give a very brief answer. 1.03. What is the ratio of the Area (in %) of Low & middle income in 1999 to that in 2002?
Provide a succinct answer. 0.96. What is the ratio of the Area (in %) of Macedonia in 1999 to that in 2002?
Offer a very short reply. 1.02. What is the ratio of the Area (in %) of Tunisia in 1999 to that in 2002?
Your response must be concise. 0.98. What is the ratio of the Area (in %) of Europe(developing only) in 1999 to that in 2003?
Ensure brevity in your answer.  1.03. What is the ratio of the Area (in %) of Low & middle income in 1999 to that in 2003?
Keep it short and to the point. 0.94. What is the ratio of the Area (in %) of Macedonia in 1999 to that in 2003?
Ensure brevity in your answer.  1.02. What is the ratio of the Area (in %) of Tunisia in 1999 to that in 2003?
Your answer should be compact. 0.98. What is the ratio of the Area (in %) in Europe(developing only) in 2000 to that in 2001?
Your response must be concise. 1.02. What is the ratio of the Area (in %) in Low & middle income in 2000 to that in 2001?
Ensure brevity in your answer.  0.98. What is the ratio of the Area (in %) in Tunisia in 2000 to that in 2001?
Offer a very short reply. 1. What is the ratio of the Area (in %) in Europe(developing only) in 2000 to that in 2002?
Make the answer very short. 1.02. What is the ratio of the Area (in %) in Low & middle income in 2000 to that in 2002?
Ensure brevity in your answer.  0.97. What is the ratio of the Area (in %) in Macedonia in 2000 to that in 2002?
Make the answer very short. 1. What is the ratio of the Area (in %) in Tunisia in 2000 to that in 2002?
Your answer should be compact. 0.99. What is the ratio of the Area (in %) of Low & middle income in 2000 to that in 2003?
Your answer should be compact. 0.96. What is the ratio of the Area (in %) in Macedonia in 2000 to that in 2003?
Your answer should be very brief. 1. What is the ratio of the Area (in %) in Tunisia in 2000 to that in 2003?
Ensure brevity in your answer.  0.99. What is the ratio of the Area (in %) in Macedonia in 2001 to that in 2002?
Make the answer very short. 1. What is the ratio of the Area (in %) in Low & middle income in 2001 to that in 2003?
Ensure brevity in your answer.  0.97. What is the ratio of the Area (in %) of Tunisia in 2001 to that in 2003?
Provide a succinct answer. 1. What is the ratio of the Area (in %) of Low & middle income in 2002 to that in 2003?
Your answer should be very brief. 0.98. What is the ratio of the Area (in %) of Macedonia in 2002 to that in 2003?
Your answer should be compact. 1. What is the difference between the highest and the second highest Area (in %) of Europe(developing only)?
Give a very brief answer. 0.02. What is the difference between the highest and the second highest Area (in %) of Low & middle income?
Provide a succinct answer. 0.03. What is the difference between the highest and the second highest Area (in %) in Macedonia?
Give a very brief answer. 0.04. What is the difference between the highest and the second highest Area (in %) of Tunisia?
Your answer should be very brief. 0.02. What is the difference between the highest and the lowest Area (in %) of Europe(developing only)?
Ensure brevity in your answer.  0.06. What is the difference between the highest and the lowest Area (in %) in Low & middle income?
Your answer should be compact. 0.13. What is the difference between the highest and the lowest Area (in %) in Macedonia?
Offer a terse response. 0.16. What is the difference between the highest and the lowest Area (in %) of Tunisia?
Provide a succinct answer. 0.44. 